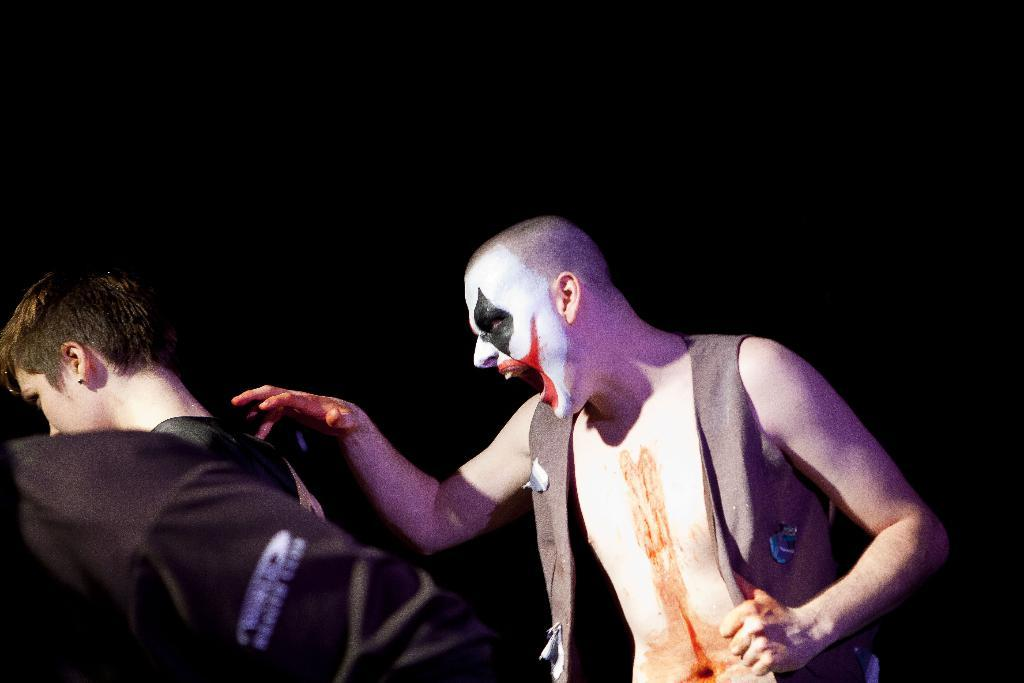What is the main subject of the image? There is a person with makeup in the image. Are there any other people in the image? Yes, there are two other people in the image. Can you describe the background of the image? The background of the image is dark. What type of picture is the person holding in the image? There is no picture visible in the image. What is the current temperature in the image? The image does not provide any information about the temperature. How many eggs are visible in the image? There are no eggs present in the image. 